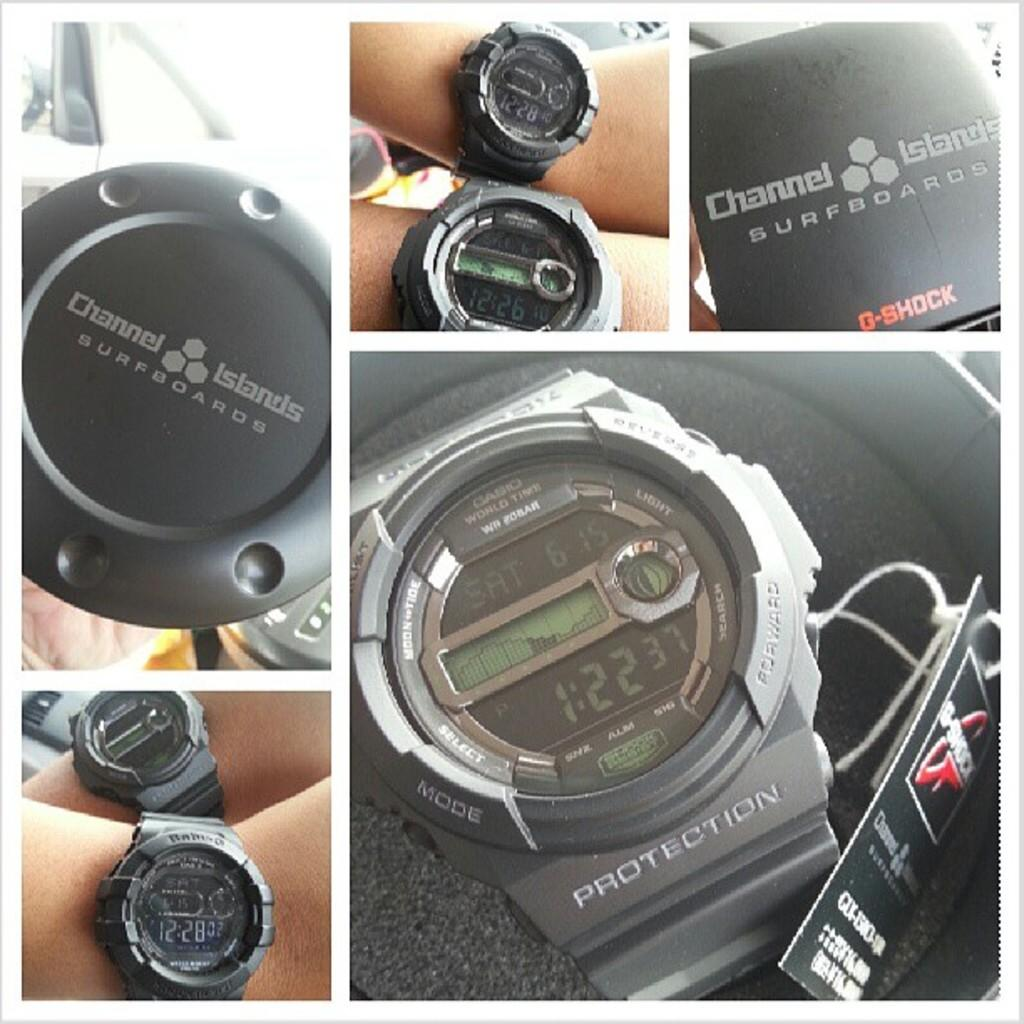<image>
Create a compact narrative representing the image presented. Collage of photos for a watch which says Channel Islands on it. 